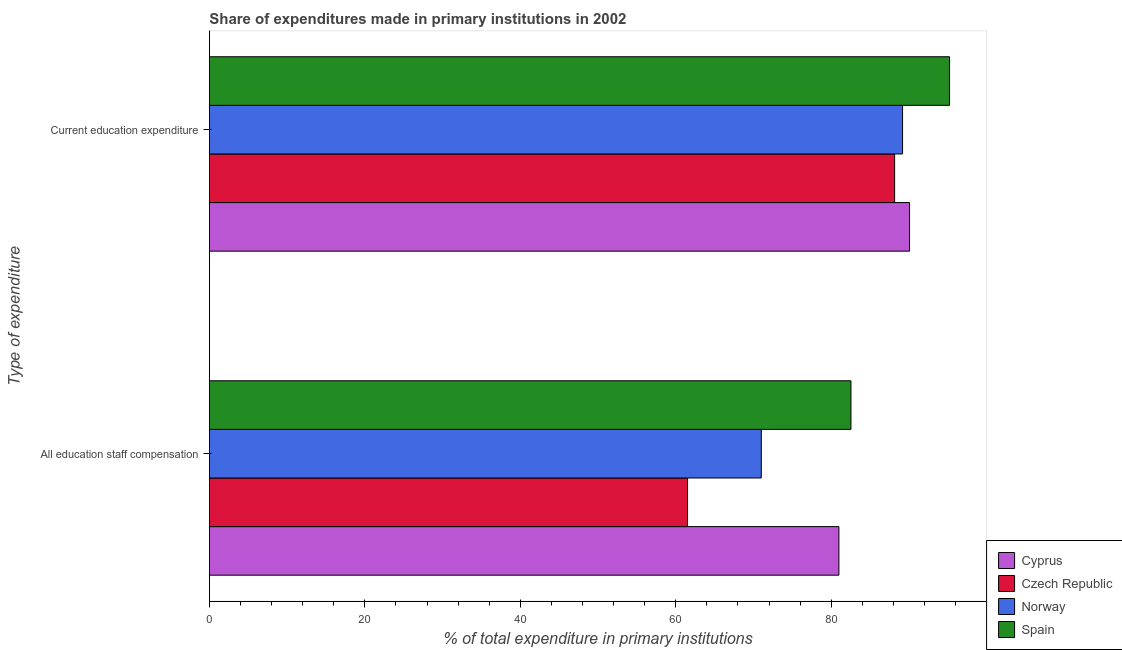How many different coloured bars are there?
Make the answer very short. 4. How many groups of bars are there?
Your answer should be very brief. 2. Are the number of bars per tick equal to the number of legend labels?
Your response must be concise. Yes. Are the number of bars on each tick of the Y-axis equal?
Offer a terse response. Yes. How many bars are there on the 2nd tick from the bottom?
Provide a succinct answer. 4. What is the label of the 2nd group of bars from the top?
Keep it short and to the point. All education staff compensation. What is the expenditure in staff compensation in Spain?
Provide a short and direct response. 82.54. Across all countries, what is the maximum expenditure in education?
Keep it short and to the point. 95.23. Across all countries, what is the minimum expenditure in staff compensation?
Provide a short and direct response. 61.52. In which country was the expenditure in staff compensation minimum?
Your answer should be very brief. Czech Republic. What is the total expenditure in staff compensation in the graph?
Ensure brevity in your answer.  296.06. What is the difference between the expenditure in staff compensation in Spain and that in Norway?
Your answer should be very brief. 11.53. What is the difference between the expenditure in education in Spain and the expenditure in staff compensation in Czech Republic?
Your response must be concise. 33.71. What is the average expenditure in education per country?
Your answer should be compact. 90.66. What is the difference between the expenditure in staff compensation and expenditure in education in Norway?
Your answer should be compact. -18.17. What is the ratio of the expenditure in staff compensation in Norway to that in Czech Republic?
Keep it short and to the point. 1.15. In how many countries, is the expenditure in education greater than the average expenditure in education taken over all countries?
Offer a terse response. 1. What does the 4th bar from the top in All education staff compensation represents?
Offer a very short reply. Cyprus. What does the 4th bar from the bottom in All education staff compensation represents?
Your response must be concise. Spain. What is the difference between two consecutive major ticks on the X-axis?
Provide a short and direct response. 20. Are the values on the major ticks of X-axis written in scientific E-notation?
Your response must be concise. No. Does the graph contain any zero values?
Provide a short and direct response. No. Does the graph contain grids?
Offer a terse response. No. How are the legend labels stacked?
Your answer should be very brief. Vertical. What is the title of the graph?
Offer a terse response. Share of expenditures made in primary institutions in 2002. What is the label or title of the X-axis?
Your response must be concise. % of total expenditure in primary institutions. What is the label or title of the Y-axis?
Make the answer very short. Type of expenditure. What is the % of total expenditure in primary institutions in Cyprus in All education staff compensation?
Provide a succinct answer. 80.99. What is the % of total expenditure in primary institutions of Czech Republic in All education staff compensation?
Provide a short and direct response. 61.52. What is the % of total expenditure in primary institutions in Norway in All education staff compensation?
Provide a succinct answer. 71.01. What is the % of total expenditure in primary institutions of Spain in All education staff compensation?
Offer a very short reply. 82.54. What is the % of total expenditure in primary institutions in Cyprus in Current education expenditure?
Offer a very short reply. 90.08. What is the % of total expenditure in primary institutions in Czech Republic in Current education expenditure?
Your response must be concise. 88.16. What is the % of total expenditure in primary institutions of Norway in Current education expenditure?
Your answer should be very brief. 89.18. What is the % of total expenditure in primary institutions in Spain in Current education expenditure?
Keep it short and to the point. 95.23. Across all Type of expenditure, what is the maximum % of total expenditure in primary institutions in Cyprus?
Make the answer very short. 90.08. Across all Type of expenditure, what is the maximum % of total expenditure in primary institutions in Czech Republic?
Your answer should be compact. 88.16. Across all Type of expenditure, what is the maximum % of total expenditure in primary institutions in Norway?
Offer a very short reply. 89.18. Across all Type of expenditure, what is the maximum % of total expenditure in primary institutions of Spain?
Offer a very short reply. 95.23. Across all Type of expenditure, what is the minimum % of total expenditure in primary institutions in Cyprus?
Your response must be concise. 80.99. Across all Type of expenditure, what is the minimum % of total expenditure in primary institutions of Czech Republic?
Provide a short and direct response. 61.52. Across all Type of expenditure, what is the minimum % of total expenditure in primary institutions of Norway?
Your answer should be very brief. 71.01. Across all Type of expenditure, what is the minimum % of total expenditure in primary institutions of Spain?
Make the answer very short. 82.54. What is the total % of total expenditure in primary institutions in Cyprus in the graph?
Provide a succinct answer. 171.07. What is the total % of total expenditure in primary institutions of Czech Republic in the graph?
Provide a succinct answer. 149.68. What is the total % of total expenditure in primary institutions of Norway in the graph?
Your answer should be compact. 160.19. What is the total % of total expenditure in primary institutions of Spain in the graph?
Keep it short and to the point. 177.77. What is the difference between the % of total expenditure in primary institutions of Cyprus in All education staff compensation and that in Current education expenditure?
Offer a terse response. -9.09. What is the difference between the % of total expenditure in primary institutions of Czech Republic in All education staff compensation and that in Current education expenditure?
Ensure brevity in your answer.  -26.64. What is the difference between the % of total expenditure in primary institutions of Norway in All education staff compensation and that in Current education expenditure?
Ensure brevity in your answer.  -18.17. What is the difference between the % of total expenditure in primary institutions of Spain in All education staff compensation and that in Current education expenditure?
Keep it short and to the point. -12.69. What is the difference between the % of total expenditure in primary institutions in Cyprus in All education staff compensation and the % of total expenditure in primary institutions in Czech Republic in Current education expenditure?
Your answer should be compact. -7.17. What is the difference between the % of total expenditure in primary institutions in Cyprus in All education staff compensation and the % of total expenditure in primary institutions in Norway in Current education expenditure?
Your answer should be compact. -8.19. What is the difference between the % of total expenditure in primary institutions in Cyprus in All education staff compensation and the % of total expenditure in primary institutions in Spain in Current education expenditure?
Ensure brevity in your answer.  -14.24. What is the difference between the % of total expenditure in primary institutions in Czech Republic in All education staff compensation and the % of total expenditure in primary institutions in Norway in Current education expenditure?
Your answer should be very brief. -27.66. What is the difference between the % of total expenditure in primary institutions of Czech Republic in All education staff compensation and the % of total expenditure in primary institutions of Spain in Current education expenditure?
Your answer should be compact. -33.71. What is the difference between the % of total expenditure in primary institutions in Norway in All education staff compensation and the % of total expenditure in primary institutions in Spain in Current education expenditure?
Ensure brevity in your answer.  -24.22. What is the average % of total expenditure in primary institutions in Cyprus per Type of expenditure?
Provide a succinct answer. 85.54. What is the average % of total expenditure in primary institutions of Czech Republic per Type of expenditure?
Offer a terse response. 74.84. What is the average % of total expenditure in primary institutions in Norway per Type of expenditure?
Your answer should be very brief. 80.09. What is the average % of total expenditure in primary institutions of Spain per Type of expenditure?
Your answer should be very brief. 88.88. What is the difference between the % of total expenditure in primary institutions in Cyprus and % of total expenditure in primary institutions in Czech Republic in All education staff compensation?
Offer a terse response. 19.47. What is the difference between the % of total expenditure in primary institutions in Cyprus and % of total expenditure in primary institutions in Norway in All education staff compensation?
Your response must be concise. 9.99. What is the difference between the % of total expenditure in primary institutions of Cyprus and % of total expenditure in primary institutions of Spain in All education staff compensation?
Make the answer very short. -1.55. What is the difference between the % of total expenditure in primary institutions of Czech Republic and % of total expenditure in primary institutions of Norway in All education staff compensation?
Your answer should be very brief. -9.49. What is the difference between the % of total expenditure in primary institutions of Czech Republic and % of total expenditure in primary institutions of Spain in All education staff compensation?
Offer a very short reply. -21.02. What is the difference between the % of total expenditure in primary institutions of Norway and % of total expenditure in primary institutions of Spain in All education staff compensation?
Make the answer very short. -11.53. What is the difference between the % of total expenditure in primary institutions of Cyprus and % of total expenditure in primary institutions of Czech Republic in Current education expenditure?
Ensure brevity in your answer.  1.92. What is the difference between the % of total expenditure in primary institutions of Cyprus and % of total expenditure in primary institutions of Norway in Current education expenditure?
Offer a very short reply. 0.9. What is the difference between the % of total expenditure in primary institutions of Cyprus and % of total expenditure in primary institutions of Spain in Current education expenditure?
Your response must be concise. -5.15. What is the difference between the % of total expenditure in primary institutions in Czech Republic and % of total expenditure in primary institutions in Norway in Current education expenditure?
Give a very brief answer. -1.02. What is the difference between the % of total expenditure in primary institutions in Czech Republic and % of total expenditure in primary institutions in Spain in Current education expenditure?
Your answer should be very brief. -7.07. What is the difference between the % of total expenditure in primary institutions of Norway and % of total expenditure in primary institutions of Spain in Current education expenditure?
Your answer should be very brief. -6.05. What is the ratio of the % of total expenditure in primary institutions in Cyprus in All education staff compensation to that in Current education expenditure?
Make the answer very short. 0.9. What is the ratio of the % of total expenditure in primary institutions of Czech Republic in All education staff compensation to that in Current education expenditure?
Offer a terse response. 0.7. What is the ratio of the % of total expenditure in primary institutions of Norway in All education staff compensation to that in Current education expenditure?
Provide a short and direct response. 0.8. What is the ratio of the % of total expenditure in primary institutions of Spain in All education staff compensation to that in Current education expenditure?
Give a very brief answer. 0.87. What is the difference between the highest and the second highest % of total expenditure in primary institutions of Cyprus?
Make the answer very short. 9.09. What is the difference between the highest and the second highest % of total expenditure in primary institutions in Czech Republic?
Provide a succinct answer. 26.64. What is the difference between the highest and the second highest % of total expenditure in primary institutions in Norway?
Your answer should be very brief. 18.17. What is the difference between the highest and the second highest % of total expenditure in primary institutions in Spain?
Provide a short and direct response. 12.69. What is the difference between the highest and the lowest % of total expenditure in primary institutions in Cyprus?
Provide a succinct answer. 9.09. What is the difference between the highest and the lowest % of total expenditure in primary institutions of Czech Republic?
Your answer should be compact. 26.64. What is the difference between the highest and the lowest % of total expenditure in primary institutions of Norway?
Make the answer very short. 18.17. What is the difference between the highest and the lowest % of total expenditure in primary institutions in Spain?
Offer a very short reply. 12.69. 